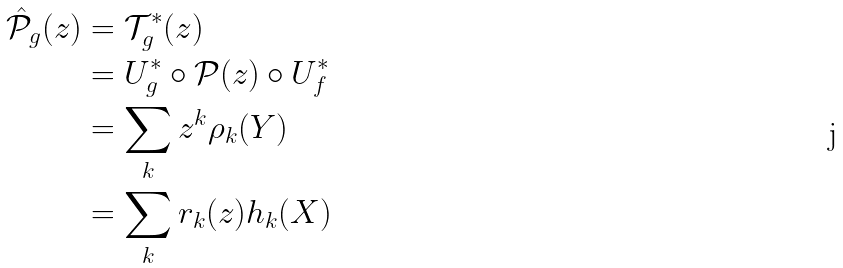<formula> <loc_0><loc_0><loc_500><loc_500>\hat { \mathcal { P } } _ { g } ( z ) & = \mathcal { T } _ { g } ^ { * } ( z ) \\ & = U _ { g } ^ { * } \circ \mathcal { P } ( z ) \circ U _ { f } ^ { * } \\ & = \sum _ { k } z ^ { k } \rho _ { k } ( Y ) \\ & = \sum _ { k } r _ { k } ( z ) h _ { k } ( X )</formula> 